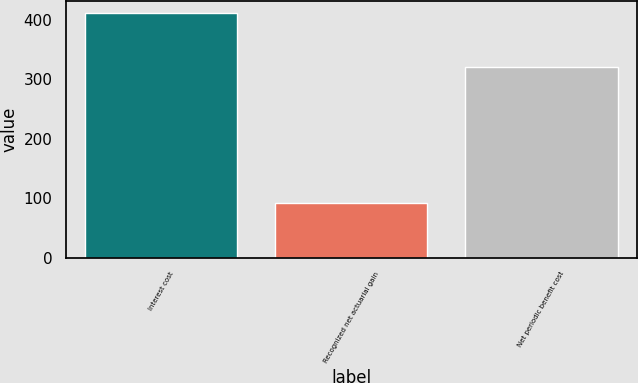Convert chart. <chart><loc_0><loc_0><loc_500><loc_500><bar_chart><fcel>Interest cost<fcel>Recognized net actuarial gain<fcel>Net periodic benefit cost<nl><fcel>411<fcel>91<fcel>320<nl></chart> 